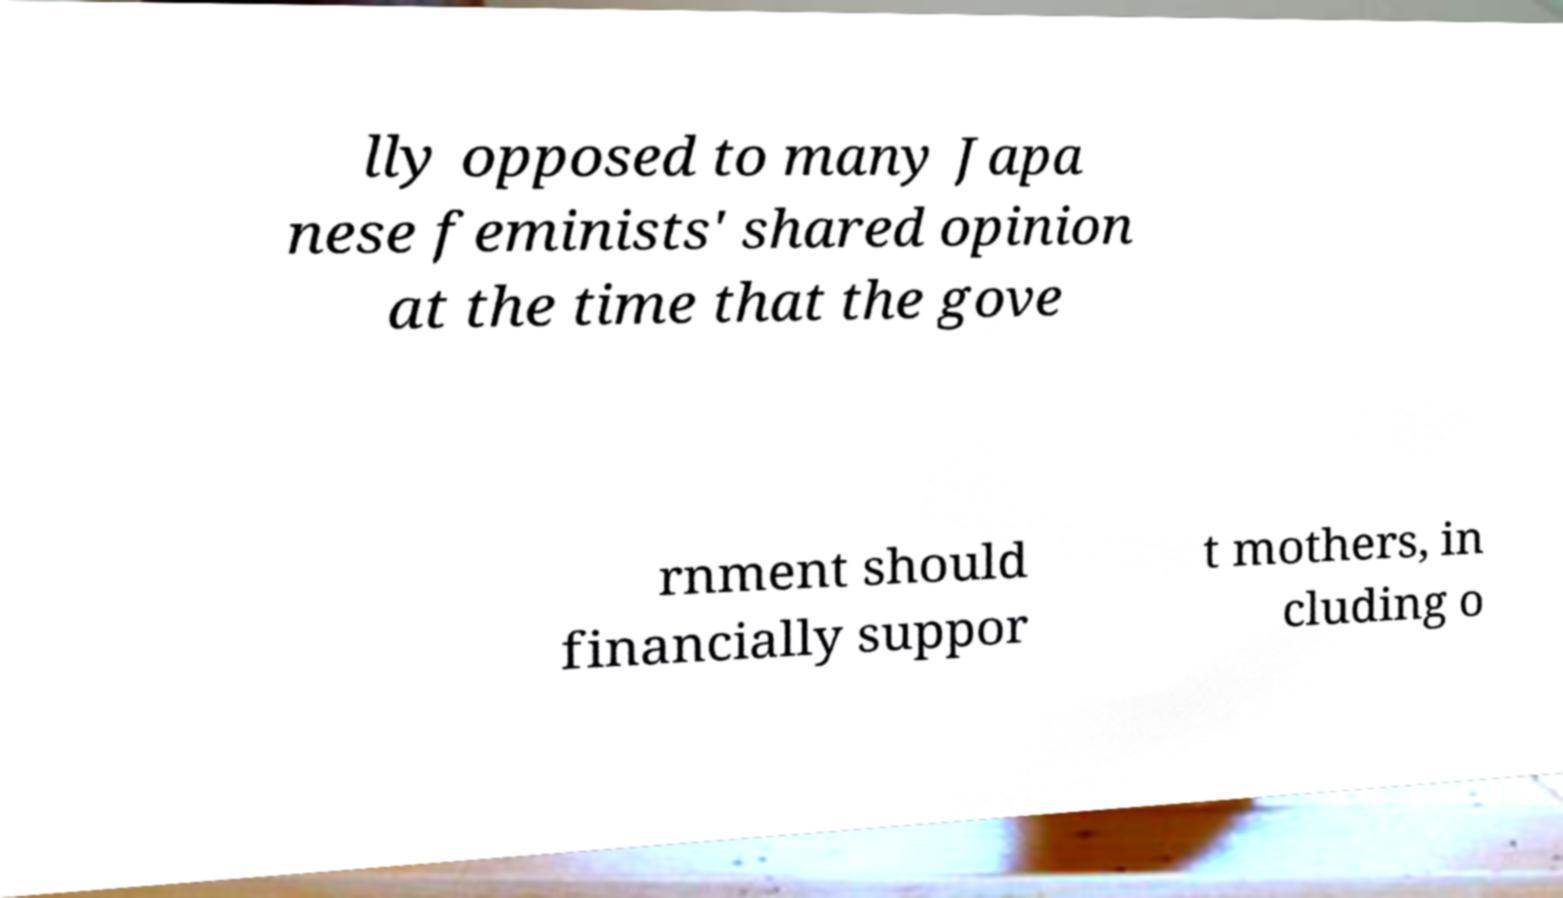Please identify and transcribe the text found in this image. lly opposed to many Japa nese feminists' shared opinion at the time that the gove rnment should financially suppor t mothers, in cluding o 